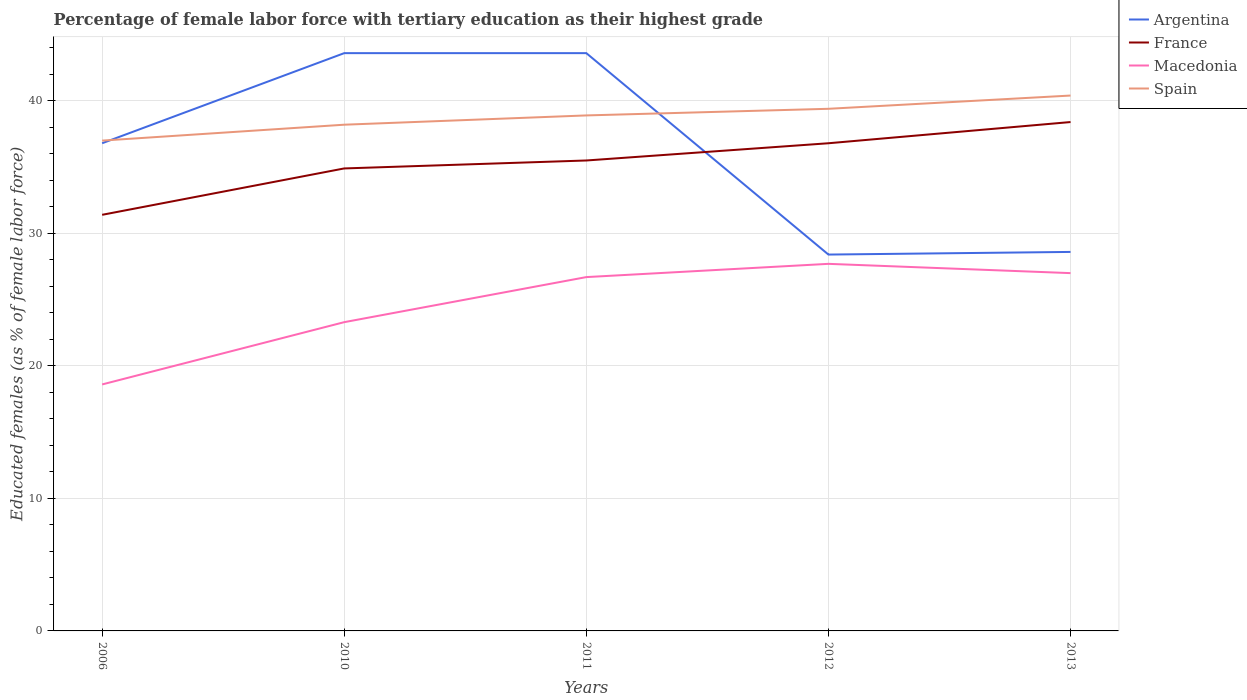Is the number of lines equal to the number of legend labels?
Keep it short and to the point. Yes. Across all years, what is the maximum percentage of female labor force with tertiary education in France?
Provide a succinct answer. 31.4. In which year was the percentage of female labor force with tertiary education in Spain maximum?
Your answer should be very brief. 2006. What is the total percentage of female labor force with tertiary education in France in the graph?
Offer a very short reply. -0.6. What is the difference between the highest and the second highest percentage of female labor force with tertiary education in Spain?
Ensure brevity in your answer.  3.4. Is the percentage of female labor force with tertiary education in Macedonia strictly greater than the percentage of female labor force with tertiary education in France over the years?
Your response must be concise. Yes. How many lines are there?
Your answer should be very brief. 4. Does the graph contain any zero values?
Your answer should be very brief. No. Where does the legend appear in the graph?
Your answer should be very brief. Top right. How many legend labels are there?
Provide a succinct answer. 4. What is the title of the graph?
Your answer should be compact. Percentage of female labor force with tertiary education as their highest grade. Does "Middle income" appear as one of the legend labels in the graph?
Provide a short and direct response. No. What is the label or title of the X-axis?
Your answer should be very brief. Years. What is the label or title of the Y-axis?
Your answer should be compact. Educated females (as % of female labor force). What is the Educated females (as % of female labor force) of Argentina in 2006?
Offer a very short reply. 36.8. What is the Educated females (as % of female labor force) in France in 2006?
Your response must be concise. 31.4. What is the Educated females (as % of female labor force) of Macedonia in 2006?
Provide a short and direct response. 18.6. What is the Educated females (as % of female labor force) of Argentina in 2010?
Give a very brief answer. 43.6. What is the Educated females (as % of female labor force) in France in 2010?
Provide a succinct answer. 34.9. What is the Educated females (as % of female labor force) of Macedonia in 2010?
Give a very brief answer. 23.3. What is the Educated females (as % of female labor force) in Spain in 2010?
Offer a very short reply. 38.2. What is the Educated females (as % of female labor force) in Argentina in 2011?
Offer a terse response. 43.6. What is the Educated females (as % of female labor force) of France in 2011?
Make the answer very short. 35.5. What is the Educated females (as % of female labor force) of Macedonia in 2011?
Your answer should be compact. 26.7. What is the Educated females (as % of female labor force) in Spain in 2011?
Make the answer very short. 38.9. What is the Educated females (as % of female labor force) of Argentina in 2012?
Provide a short and direct response. 28.4. What is the Educated females (as % of female labor force) in France in 2012?
Make the answer very short. 36.8. What is the Educated females (as % of female labor force) of Macedonia in 2012?
Provide a short and direct response. 27.7. What is the Educated females (as % of female labor force) in Spain in 2012?
Your response must be concise. 39.4. What is the Educated females (as % of female labor force) in Argentina in 2013?
Your response must be concise. 28.6. What is the Educated females (as % of female labor force) of France in 2013?
Provide a short and direct response. 38.4. What is the Educated females (as % of female labor force) of Spain in 2013?
Give a very brief answer. 40.4. Across all years, what is the maximum Educated females (as % of female labor force) of Argentina?
Ensure brevity in your answer.  43.6. Across all years, what is the maximum Educated females (as % of female labor force) of France?
Provide a succinct answer. 38.4. Across all years, what is the maximum Educated females (as % of female labor force) of Macedonia?
Keep it short and to the point. 27.7. Across all years, what is the maximum Educated females (as % of female labor force) of Spain?
Make the answer very short. 40.4. Across all years, what is the minimum Educated females (as % of female labor force) of Argentina?
Offer a very short reply. 28.4. Across all years, what is the minimum Educated females (as % of female labor force) of France?
Your answer should be very brief. 31.4. Across all years, what is the minimum Educated females (as % of female labor force) of Macedonia?
Your answer should be very brief. 18.6. Across all years, what is the minimum Educated females (as % of female labor force) of Spain?
Give a very brief answer. 37. What is the total Educated females (as % of female labor force) in Argentina in the graph?
Provide a short and direct response. 181. What is the total Educated females (as % of female labor force) of France in the graph?
Offer a terse response. 177. What is the total Educated females (as % of female labor force) of Macedonia in the graph?
Provide a short and direct response. 123.3. What is the total Educated females (as % of female labor force) of Spain in the graph?
Your response must be concise. 193.9. What is the difference between the Educated females (as % of female labor force) of Spain in 2006 and that in 2010?
Your response must be concise. -1.2. What is the difference between the Educated females (as % of female labor force) in France in 2006 and that in 2011?
Ensure brevity in your answer.  -4.1. What is the difference between the Educated females (as % of female labor force) in Spain in 2006 and that in 2011?
Keep it short and to the point. -1.9. What is the difference between the Educated females (as % of female labor force) in Macedonia in 2006 and that in 2012?
Your answer should be compact. -9.1. What is the difference between the Educated females (as % of female labor force) in France in 2010 and that in 2011?
Give a very brief answer. -0.6. What is the difference between the Educated females (as % of female labor force) of Spain in 2010 and that in 2011?
Offer a terse response. -0.7. What is the difference between the Educated females (as % of female labor force) of France in 2010 and that in 2012?
Ensure brevity in your answer.  -1.9. What is the difference between the Educated females (as % of female labor force) in Macedonia in 2010 and that in 2012?
Keep it short and to the point. -4.4. What is the difference between the Educated females (as % of female labor force) in France in 2010 and that in 2013?
Ensure brevity in your answer.  -3.5. What is the difference between the Educated females (as % of female labor force) of Macedonia in 2010 and that in 2013?
Your answer should be very brief. -3.7. What is the difference between the Educated females (as % of female labor force) in Argentina in 2011 and that in 2012?
Your answer should be very brief. 15.2. What is the difference between the Educated females (as % of female labor force) in Spain in 2011 and that in 2012?
Your answer should be compact. -0.5. What is the difference between the Educated females (as % of female labor force) in France in 2011 and that in 2013?
Provide a succinct answer. -2.9. What is the difference between the Educated females (as % of female labor force) of Macedonia in 2011 and that in 2013?
Your answer should be compact. -0.3. What is the difference between the Educated females (as % of female labor force) in Argentina in 2012 and that in 2013?
Keep it short and to the point. -0.2. What is the difference between the Educated females (as % of female labor force) of France in 2012 and that in 2013?
Provide a short and direct response. -1.6. What is the difference between the Educated females (as % of female labor force) in Macedonia in 2012 and that in 2013?
Keep it short and to the point. 0.7. What is the difference between the Educated females (as % of female labor force) of Spain in 2012 and that in 2013?
Keep it short and to the point. -1. What is the difference between the Educated females (as % of female labor force) of Argentina in 2006 and the Educated females (as % of female labor force) of Macedonia in 2010?
Keep it short and to the point. 13.5. What is the difference between the Educated females (as % of female labor force) of Argentina in 2006 and the Educated females (as % of female labor force) of Spain in 2010?
Ensure brevity in your answer.  -1.4. What is the difference between the Educated females (as % of female labor force) of Macedonia in 2006 and the Educated females (as % of female labor force) of Spain in 2010?
Offer a terse response. -19.6. What is the difference between the Educated females (as % of female labor force) in Argentina in 2006 and the Educated females (as % of female labor force) in Spain in 2011?
Make the answer very short. -2.1. What is the difference between the Educated females (as % of female labor force) of France in 2006 and the Educated females (as % of female labor force) of Spain in 2011?
Make the answer very short. -7.5. What is the difference between the Educated females (as % of female labor force) of Macedonia in 2006 and the Educated females (as % of female labor force) of Spain in 2011?
Offer a terse response. -20.3. What is the difference between the Educated females (as % of female labor force) in Argentina in 2006 and the Educated females (as % of female labor force) in Macedonia in 2012?
Offer a very short reply. 9.1. What is the difference between the Educated females (as % of female labor force) of Macedonia in 2006 and the Educated females (as % of female labor force) of Spain in 2012?
Your answer should be very brief. -20.8. What is the difference between the Educated females (as % of female labor force) of France in 2006 and the Educated females (as % of female labor force) of Macedonia in 2013?
Your answer should be very brief. 4.4. What is the difference between the Educated females (as % of female labor force) of France in 2006 and the Educated females (as % of female labor force) of Spain in 2013?
Your answer should be compact. -9. What is the difference between the Educated females (as % of female labor force) in Macedonia in 2006 and the Educated females (as % of female labor force) in Spain in 2013?
Give a very brief answer. -21.8. What is the difference between the Educated females (as % of female labor force) of Argentina in 2010 and the Educated females (as % of female labor force) of France in 2011?
Give a very brief answer. 8.1. What is the difference between the Educated females (as % of female labor force) in Argentina in 2010 and the Educated females (as % of female labor force) in Spain in 2011?
Ensure brevity in your answer.  4.7. What is the difference between the Educated females (as % of female labor force) in Macedonia in 2010 and the Educated females (as % of female labor force) in Spain in 2011?
Keep it short and to the point. -15.6. What is the difference between the Educated females (as % of female labor force) of Argentina in 2010 and the Educated females (as % of female labor force) of Macedonia in 2012?
Your answer should be compact. 15.9. What is the difference between the Educated females (as % of female labor force) in Argentina in 2010 and the Educated females (as % of female labor force) in Spain in 2012?
Your answer should be very brief. 4.2. What is the difference between the Educated females (as % of female labor force) of France in 2010 and the Educated females (as % of female labor force) of Spain in 2012?
Ensure brevity in your answer.  -4.5. What is the difference between the Educated females (as % of female labor force) of Macedonia in 2010 and the Educated females (as % of female labor force) of Spain in 2012?
Your response must be concise. -16.1. What is the difference between the Educated females (as % of female labor force) of Argentina in 2010 and the Educated females (as % of female labor force) of France in 2013?
Your answer should be very brief. 5.2. What is the difference between the Educated females (as % of female labor force) in Argentina in 2010 and the Educated females (as % of female labor force) in Macedonia in 2013?
Give a very brief answer. 16.6. What is the difference between the Educated females (as % of female labor force) in France in 2010 and the Educated females (as % of female labor force) in Macedonia in 2013?
Ensure brevity in your answer.  7.9. What is the difference between the Educated females (as % of female labor force) in France in 2010 and the Educated females (as % of female labor force) in Spain in 2013?
Offer a terse response. -5.5. What is the difference between the Educated females (as % of female labor force) of Macedonia in 2010 and the Educated females (as % of female labor force) of Spain in 2013?
Keep it short and to the point. -17.1. What is the difference between the Educated females (as % of female labor force) of Argentina in 2011 and the Educated females (as % of female labor force) of France in 2012?
Your answer should be compact. 6.8. What is the difference between the Educated females (as % of female labor force) in France in 2011 and the Educated females (as % of female labor force) in Macedonia in 2012?
Your response must be concise. 7.8. What is the difference between the Educated females (as % of female labor force) of Macedonia in 2011 and the Educated females (as % of female labor force) of Spain in 2012?
Offer a terse response. -12.7. What is the difference between the Educated females (as % of female labor force) of Argentina in 2011 and the Educated females (as % of female labor force) of France in 2013?
Give a very brief answer. 5.2. What is the difference between the Educated females (as % of female labor force) in Argentina in 2011 and the Educated females (as % of female labor force) in Macedonia in 2013?
Make the answer very short. 16.6. What is the difference between the Educated females (as % of female labor force) in Argentina in 2011 and the Educated females (as % of female labor force) in Spain in 2013?
Ensure brevity in your answer.  3.2. What is the difference between the Educated females (as % of female labor force) in France in 2011 and the Educated females (as % of female labor force) in Macedonia in 2013?
Make the answer very short. 8.5. What is the difference between the Educated females (as % of female labor force) in France in 2011 and the Educated females (as % of female labor force) in Spain in 2013?
Provide a short and direct response. -4.9. What is the difference between the Educated females (as % of female labor force) in Macedonia in 2011 and the Educated females (as % of female labor force) in Spain in 2013?
Your answer should be compact. -13.7. What is the difference between the Educated females (as % of female labor force) in Argentina in 2012 and the Educated females (as % of female labor force) in Macedonia in 2013?
Give a very brief answer. 1.4. What is the difference between the Educated females (as % of female labor force) of France in 2012 and the Educated females (as % of female labor force) of Spain in 2013?
Ensure brevity in your answer.  -3.6. What is the average Educated females (as % of female labor force) in Argentina per year?
Give a very brief answer. 36.2. What is the average Educated females (as % of female labor force) of France per year?
Offer a very short reply. 35.4. What is the average Educated females (as % of female labor force) of Macedonia per year?
Make the answer very short. 24.66. What is the average Educated females (as % of female labor force) in Spain per year?
Provide a succinct answer. 38.78. In the year 2006, what is the difference between the Educated females (as % of female labor force) of Argentina and Educated females (as % of female labor force) of Spain?
Make the answer very short. -0.2. In the year 2006, what is the difference between the Educated females (as % of female labor force) of France and Educated females (as % of female labor force) of Spain?
Keep it short and to the point. -5.6. In the year 2006, what is the difference between the Educated females (as % of female labor force) in Macedonia and Educated females (as % of female labor force) in Spain?
Offer a very short reply. -18.4. In the year 2010, what is the difference between the Educated females (as % of female labor force) in Argentina and Educated females (as % of female labor force) in France?
Your response must be concise. 8.7. In the year 2010, what is the difference between the Educated females (as % of female labor force) of Argentina and Educated females (as % of female labor force) of Macedonia?
Ensure brevity in your answer.  20.3. In the year 2010, what is the difference between the Educated females (as % of female labor force) in France and Educated females (as % of female labor force) in Macedonia?
Give a very brief answer. 11.6. In the year 2010, what is the difference between the Educated females (as % of female labor force) of France and Educated females (as % of female labor force) of Spain?
Your answer should be compact. -3.3. In the year 2010, what is the difference between the Educated females (as % of female labor force) in Macedonia and Educated females (as % of female labor force) in Spain?
Your answer should be compact. -14.9. In the year 2011, what is the difference between the Educated females (as % of female labor force) in Argentina and Educated females (as % of female labor force) in France?
Ensure brevity in your answer.  8.1. In the year 2011, what is the difference between the Educated females (as % of female labor force) of Argentina and Educated females (as % of female labor force) of Spain?
Keep it short and to the point. 4.7. In the year 2011, what is the difference between the Educated females (as % of female labor force) in France and Educated females (as % of female labor force) in Spain?
Offer a terse response. -3.4. In the year 2011, what is the difference between the Educated females (as % of female labor force) of Macedonia and Educated females (as % of female labor force) of Spain?
Make the answer very short. -12.2. In the year 2012, what is the difference between the Educated females (as % of female labor force) of Argentina and Educated females (as % of female labor force) of Spain?
Give a very brief answer. -11. In the year 2012, what is the difference between the Educated females (as % of female labor force) in France and Educated females (as % of female labor force) in Macedonia?
Offer a very short reply. 9.1. In the year 2013, what is the difference between the Educated females (as % of female labor force) in Argentina and Educated females (as % of female labor force) in France?
Your response must be concise. -9.8. In the year 2013, what is the difference between the Educated females (as % of female labor force) in Argentina and Educated females (as % of female labor force) in Macedonia?
Ensure brevity in your answer.  1.6. In the year 2013, what is the difference between the Educated females (as % of female labor force) of France and Educated females (as % of female labor force) of Macedonia?
Give a very brief answer. 11.4. In the year 2013, what is the difference between the Educated females (as % of female labor force) in France and Educated females (as % of female labor force) in Spain?
Make the answer very short. -2. In the year 2013, what is the difference between the Educated females (as % of female labor force) in Macedonia and Educated females (as % of female labor force) in Spain?
Your answer should be compact. -13.4. What is the ratio of the Educated females (as % of female labor force) in Argentina in 2006 to that in 2010?
Make the answer very short. 0.84. What is the ratio of the Educated females (as % of female labor force) in France in 2006 to that in 2010?
Your response must be concise. 0.9. What is the ratio of the Educated females (as % of female labor force) in Macedonia in 2006 to that in 2010?
Give a very brief answer. 0.8. What is the ratio of the Educated females (as % of female labor force) in Spain in 2006 to that in 2010?
Give a very brief answer. 0.97. What is the ratio of the Educated females (as % of female labor force) of Argentina in 2006 to that in 2011?
Provide a short and direct response. 0.84. What is the ratio of the Educated females (as % of female labor force) in France in 2006 to that in 2011?
Provide a short and direct response. 0.88. What is the ratio of the Educated females (as % of female labor force) of Macedonia in 2006 to that in 2011?
Provide a short and direct response. 0.7. What is the ratio of the Educated females (as % of female labor force) of Spain in 2006 to that in 2011?
Your response must be concise. 0.95. What is the ratio of the Educated females (as % of female labor force) of Argentina in 2006 to that in 2012?
Give a very brief answer. 1.3. What is the ratio of the Educated females (as % of female labor force) of France in 2006 to that in 2012?
Make the answer very short. 0.85. What is the ratio of the Educated females (as % of female labor force) in Macedonia in 2006 to that in 2012?
Provide a succinct answer. 0.67. What is the ratio of the Educated females (as % of female labor force) of Spain in 2006 to that in 2012?
Your answer should be very brief. 0.94. What is the ratio of the Educated females (as % of female labor force) of Argentina in 2006 to that in 2013?
Your answer should be very brief. 1.29. What is the ratio of the Educated females (as % of female labor force) in France in 2006 to that in 2013?
Keep it short and to the point. 0.82. What is the ratio of the Educated females (as % of female labor force) of Macedonia in 2006 to that in 2013?
Your answer should be compact. 0.69. What is the ratio of the Educated females (as % of female labor force) in Spain in 2006 to that in 2013?
Give a very brief answer. 0.92. What is the ratio of the Educated females (as % of female labor force) in France in 2010 to that in 2011?
Keep it short and to the point. 0.98. What is the ratio of the Educated females (as % of female labor force) in Macedonia in 2010 to that in 2011?
Provide a short and direct response. 0.87. What is the ratio of the Educated females (as % of female labor force) of Argentina in 2010 to that in 2012?
Give a very brief answer. 1.54. What is the ratio of the Educated females (as % of female labor force) in France in 2010 to that in 2012?
Keep it short and to the point. 0.95. What is the ratio of the Educated females (as % of female labor force) of Macedonia in 2010 to that in 2012?
Offer a very short reply. 0.84. What is the ratio of the Educated females (as % of female labor force) of Spain in 2010 to that in 2012?
Make the answer very short. 0.97. What is the ratio of the Educated females (as % of female labor force) in Argentina in 2010 to that in 2013?
Your answer should be compact. 1.52. What is the ratio of the Educated females (as % of female labor force) in France in 2010 to that in 2013?
Make the answer very short. 0.91. What is the ratio of the Educated females (as % of female labor force) in Macedonia in 2010 to that in 2013?
Make the answer very short. 0.86. What is the ratio of the Educated females (as % of female labor force) in Spain in 2010 to that in 2013?
Give a very brief answer. 0.95. What is the ratio of the Educated females (as % of female labor force) of Argentina in 2011 to that in 2012?
Offer a terse response. 1.54. What is the ratio of the Educated females (as % of female labor force) in France in 2011 to that in 2012?
Ensure brevity in your answer.  0.96. What is the ratio of the Educated females (as % of female labor force) of Macedonia in 2011 to that in 2012?
Make the answer very short. 0.96. What is the ratio of the Educated females (as % of female labor force) in Spain in 2011 to that in 2012?
Your answer should be very brief. 0.99. What is the ratio of the Educated females (as % of female labor force) of Argentina in 2011 to that in 2013?
Your answer should be very brief. 1.52. What is the ratio of the Educated females (as % of female labor force) of France in 2011 to that in 2013?
Provide a short and direct response. 0.92. What is the ratio of the Educated females (as % of female labor force) of Macedonia in 2011 to that in 2013?
Provide a succinct answer. 0.99. What is the ratio of the Educated females (as % of female labor force) in Spain in 2011 to that in 2013?
Give a very brief answer. 0.96. What is the ratio of the Educated females (as % of female labor force) of Argentina in 2012 to that in 2013?
Offer a terse response. 0.99. What is the ratio of the Educated females (as % of female labor force) in Macedonia in 2012 to that in 2013?
Offer a terse response. 1.03. What is the ratio of the Educated females (as % of female labor force) of Spain in 2012 to that in 2013?
Offer a terse response. 0.98. What is the difference between the highest and the second highest Educated females (as % of female labor force) in Spain?
Your answer should be very brief. 1. What is the difference between the highest and the lowest Educated females (as % of female labor force) of Macedonia?
Provide a short and direct response. 9.1. 